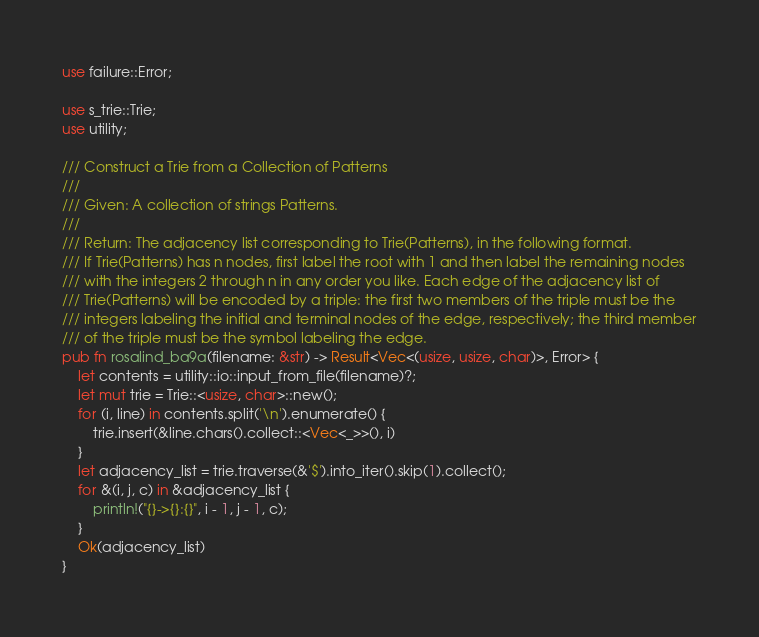Convert code to text. <code><loc_0><loc_0><loc_500><loc_500><_Rust_>use failure::Error;

use s_trie::Trie;
use utility;

/// Construct a Trie from a Collection of Patterns
///
/// Given: A collection of strings Patterns.
///
/// Return: The adjacency list corresponding to Trie(Patterns), in the following format.
/// If Trie(Patterns) has n nodes, first label the root with 1 and then label the remaining nodes
/// with the integers 2 through n in any order you like. Each edge of the adjacency list of
/// Trie(Patterns) will be encoded by a triple: the first two members of the triple must be the
/// integers labeling the initial and terminal nodes of the edge, respectively; the third member
/// of the triple must be the symbol labeling the edge.
pub fn rosalind_ba9a(filename: &str) -> Result<Vec<(usize, usize, char)>, Error> {
    let contents = utility::io::input_from_file(filename)?;
    let mut trie = Trie::<usize, char>::new();
    for (i, line) in contents.split('\n').enumerate() {
        trie.insert(&line.chars().collect::<Vec<_>>(), i)
    }
    let adjacency_list = trie.traverse(&'$').into_iter().skip(1).collect();
    for &(i, j, c) in &adjacency_list {
        println!("{}->{}:{}", i - 1, j - 1, c);
    }
    Ok(adjacency_list)
}
</code> 